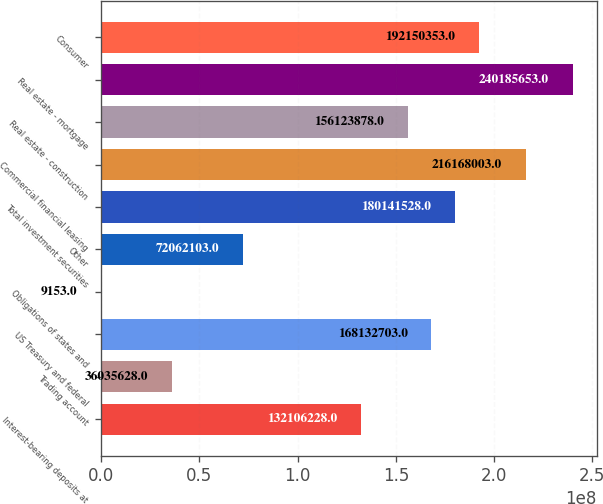Convert chart. <chart><loc_0><loc_0><loc_500><loc_500><bar_chart><fcel>Interest-bearing deposits at<fcel>Trading account<fcel>US Treasury and federal<fcel>Obligations of states and<fcel>Other<fcel>Total investment securities<fcel>Commercial financial leasing<fcel>Real estate - construction<fcel>Real estate - mortgage<fcel>Consumer<nl><fcel>1.32106e+08<fcel>3.60356e+07<fcel>1.68133e+08<fcel>9153<fcel>7.20621e+07<fcel>1.80142e+08<fcel>2.16168e+08<fcel>1.56124e+08<fcel>2.40186e+08<fcel>1.9215e+08<nl></chart> 